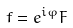Convert formula to latex. <formula><loc_0><loc_0><loc_500><loc_500>f = e ^ { i \varphi } F</formula> 